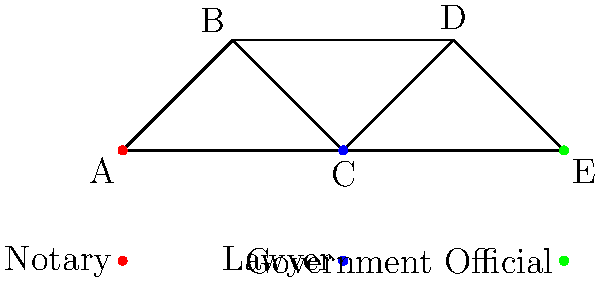В представленном сетевом графике профессиональных связей между нотариусами, юристами и государственными чиновниками, какой узел имеет наибольшее количество прямых связей? Чтобы ответить на этот вопрос, нужно проанализировать количество прямых связей для каждого узла:

1. Узел A (нотариус): имеет 2 связи (с B и C)
2. Узел B (юрист): имеет 2 связи (с A и D)
3. Узел C (нотариус): имеет 3 связи (с A, B и E)
4. Узел D (юрист): имеет 2 связи (с B и E)
5. Узел E (государственный чиновник): имеет 2 связи (с C и D)

Таким образом, узел C имеет наибольшее количество прямых связей - 3.
Answer: C 